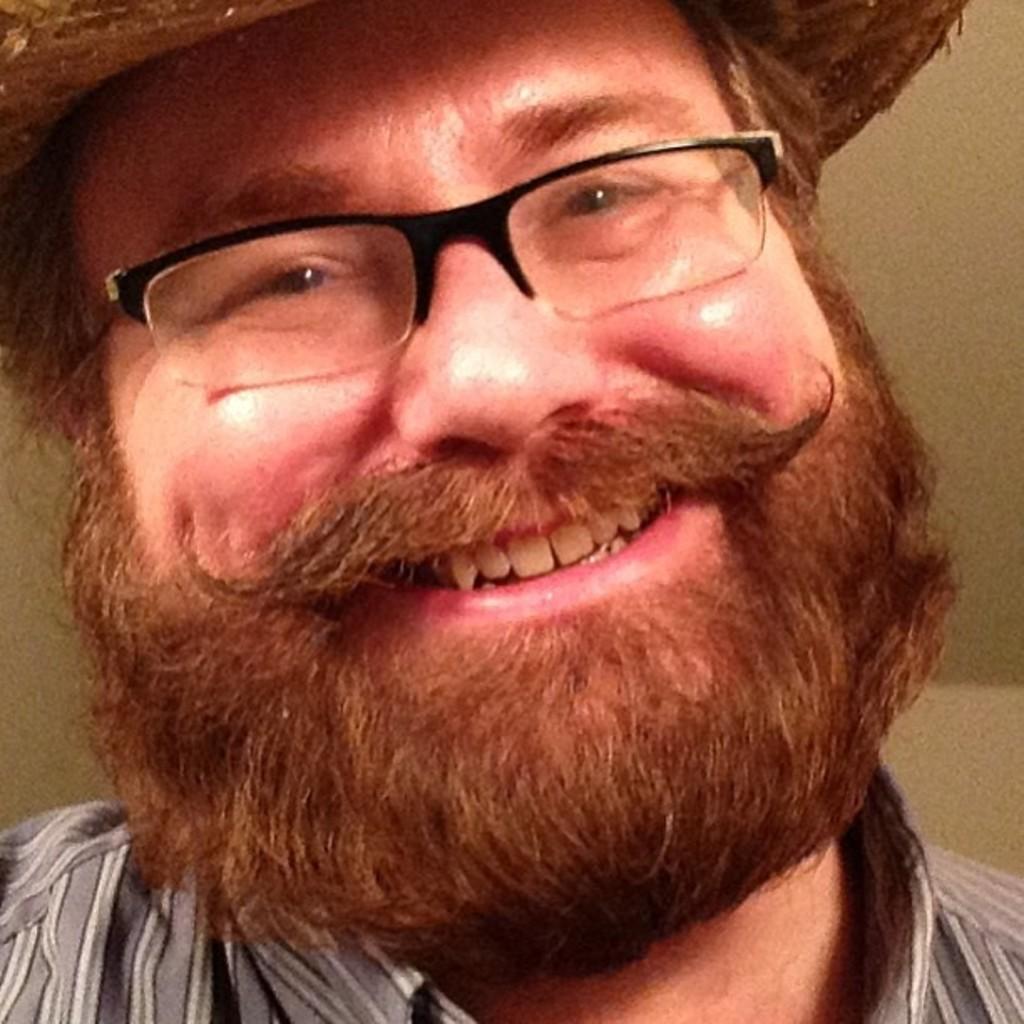How would you summarize this image in a sentence or two? In this image, we can see a man, he is wearing specs and he is smiling. 